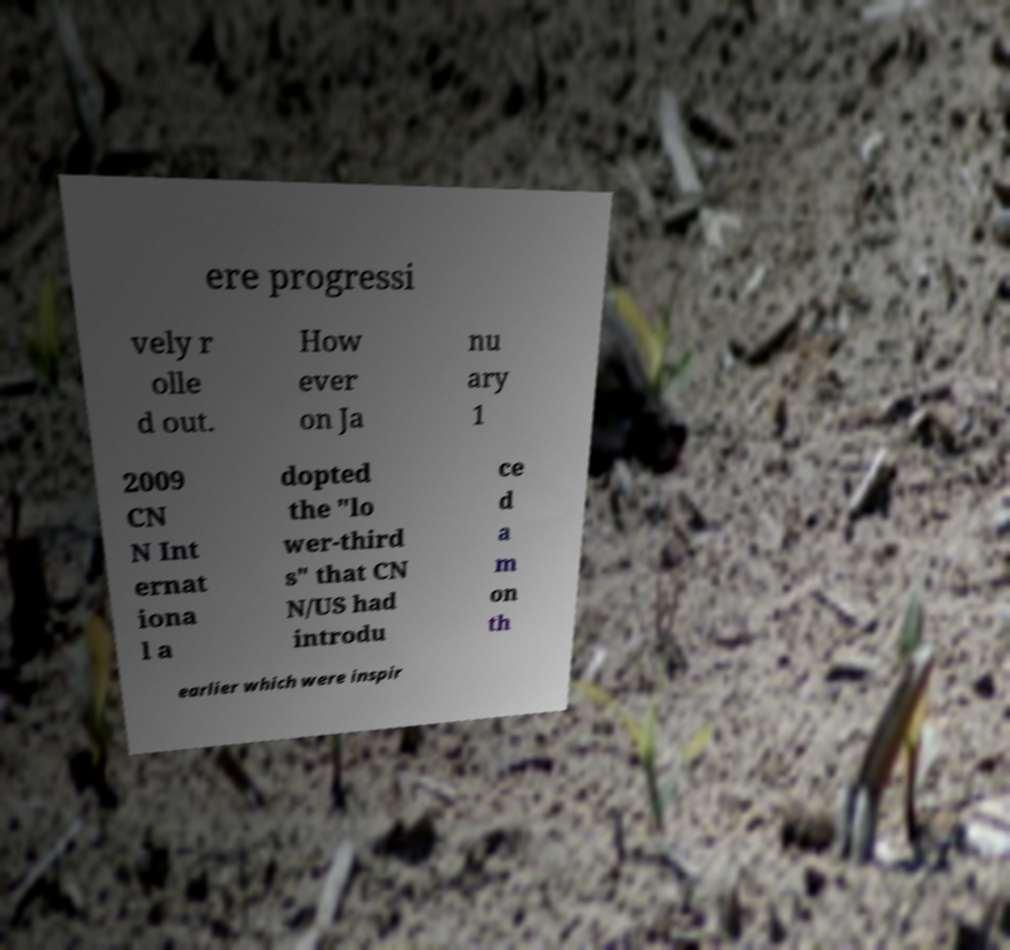For documentation purposes, I need the text within this image transcribed. Could you provide that? ere progressi vely r olle d out. How ever on Ja nu ary 1 2009 CN N Int ernat iona l a dopted the "lo wer-third s" that CN N/US had introdu ce d a m on th earlier which were inspir 